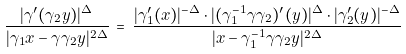<formula> <loc_0><loc_0><loc_500><loc_500>\frac { | \gamma ^ { \prime } ( \gamma _ { 2 } { y } ) | ^ { \Delta } } { | \gamma _ { 1 } { x } - \gamma \gamma _ { 2 } { y } | ^ { 2 \Delta } } \, = \, \frac { | \gamma ^ { \prime } _ { 1 } ( { x } ) | ^ { - \Delta } \cdot | ( \gamma _ { 1 } ^ { - 1 } \gamma \gamma _ { 2 } ) ^ { \prime } ( { y } ) | ^ { \Delta } \cdot | \gamma ^ { \prime } _ { 2 } ( { y } ) | ^ { - \Delta } } { | { x } - \gamma ^ { - 1 } _ { 1 } \gamma \gamma _ { 2 } { y } | ^ { 2 \Delta } }</formula> 